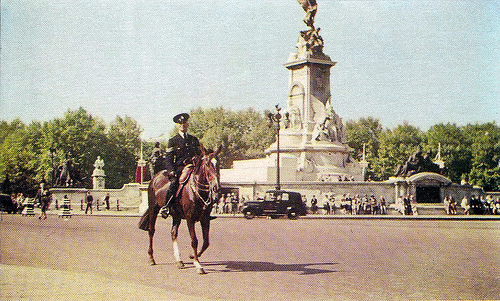Are there any interesting details about the vehicles in the scene? The vehicles in this image give a hint about the time period depicted, due to their vintage designs which suggest this photo was taken several decades ago. The presence of older model cars can sometimes tell us about the context of the time and may interest vintage car enthusiasts. Each car's design elements like the shape, trim, and possibly even the manufacturer's emblem if visible, could offer more insights into the era and the prevalent automotive trends of that time. 